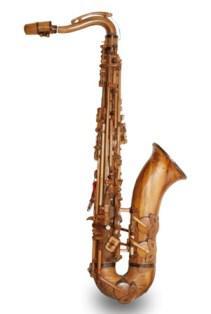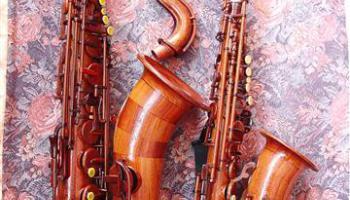The first image is the image on the left, the second image is the image on the right. For the images displayed, is the sentence "The left image shows one instrument on a white background." factually correct? Answer yes or no. Yes. The first image is the image on the left, the second image is the image on the right. Given the left and right images, does the statement "One of the instruments has a plain white background." hold true? Answer yes or no. Yes. 